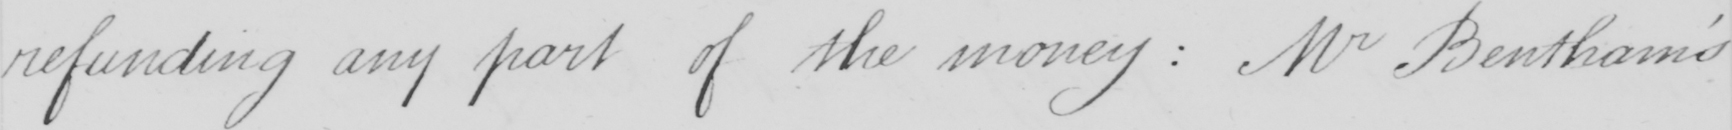Can you read and transcribe this handwriting? refunding any part of the money :  Mr Bentham ' s 